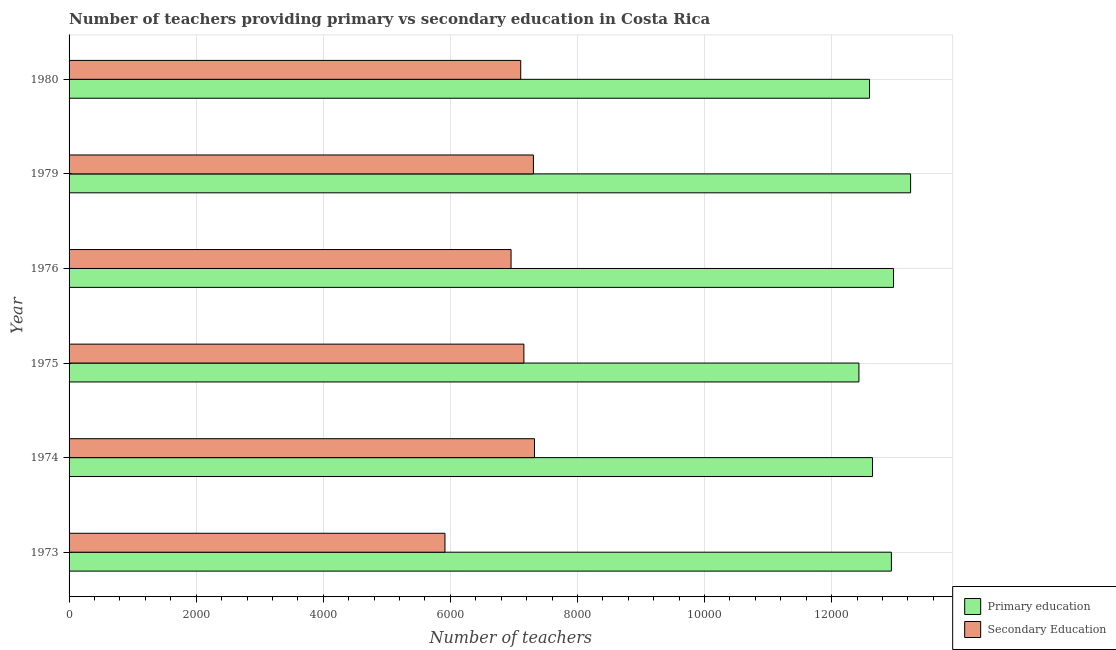How many groups of bars are there?
Provide a succinct answer. 6. How many bars are there on the 5th tick from the top?
Make the answer very short. 2. How many bars are there on the 5th tick from the bottom?
Offer a very short reply. 2. What is the label of the 3rd group of bars from the top?
Give a very brief answer. 1976. What is the number of secondary teachers in 1974?
Give a very brief answer. 7324. Across all years, what is the maximum number of secondary teachers?
Provide a succinct answer. 7324. Across all years, what is the minimum number of secondary teachers?
Offer a terse response. 5915. In which year was the number of secondary teachers maximum?
Offer a very short reply. 1974. In which year was the number of primary teachers minimum?
Your answer should be compact. 1975. What is the total number of secondary teachers in the graph?
Keep it short and to the point. 4.18e+04. What is the difference between the number of secondary teachers in 1973 and that in 1975?
Your answer should be compact. -1242. What is the difference between the number of primary teachers in 1973 and the number of secondary teachers in 1979?
Your response must be concise. 5633. What is the average number of secondary teachers per year?
Your answer should be very brief. 6960.83. In the year 1979, what is the difference between the number of secondary teachers and number of primary teachers?
Offer a terse response. -5935. What is the ratio of the number of secondary teachers in 1973 to that in 1975?
Your response must be concise. 0.83. Is the number of secondary teachers in 1974 less than that in 1979?
Give a very brief answer. No. What is the difference between the highest and the second highest number of primary teachers?
Make the answer very short. 269. What is the difference between the highest and the lowest number of primary teachers?
Your response must be concise. 813. What does the 2nd bar from the top in 1975 represents?
Give a very brief answer. Primary education. How many bars are there?
Offer a terse response. 12. How many years are there in the graph?
Your answer should be very brief. 6. What is the difference between two consecutive major ticks on the X-axis?
Your answer should be compact. 2000. Are the values on the major ticks of X-axis written in scientific E-notation?
Your answer should be compact. No. Does the graph contain any zero values?
Make the answer very short. No. Where does the legend appear in the graph?
Keep it short and to the point. Bottom right. What is the title of the graph?
Ensure brevity in your answer.  Number of teachers providing primary vs secondary education in Costa Rica. Does "By country of asylum" appear as one of the legend labels in the graph?
Provide a short and direct response. No. What is the label or title of the X-axis?
Ensure brevity in your answer.  Number of teachers. What is the label or title of the Y-axis?
Your answer should be compact. Year. What is the Number of teachers of Primary education in 1973?
Ensure brevity in your answer.  1.29e+04. What is the Number of teachers of Secondary Education in 1973?
Give a very brief answer. 5915. What is the Number of teachers of Primary education in 1974?
Provide a succinct answer. 1.26e+04. What is the Number of teachers in Secondary Education in 1974?
Your answer should be very brief. 7324. What is the Number of teachers of Primary education in 1975?
Offer a very short reply. 1.24e+04. What is the Number of teachers of Secondary Education in 1975?
Give a very brief answer. 7157. What is the Number of teachers in Primary education in 1976?
Give a very brief answer. 1.30e+04. What is the Number of teachers in Secondary Education in 1976?
Make the answer very short. 6955. What is the Number of teachers of Primary education in 1979?
Ensure brevity in your answer.  1.32e+04. What is the Number of teachers in Secondary Education in 1979?
Provide a succinct answer. 7307. What is the Number of teachers in Primary education in 1980?
Keep it short and to the point. 1.26e+04. What is the Number of teachers of Secondary Education in 1980?
Make the answer very short. 7107. Across all years, what is the maximum Number of teachers of Primary education?
Your answer should be compact. 1.32e+04. Across all years, what is the maximum Number of teachers of Secondary Education?
Keep it short and to the point. 7324. Across all years, what is the minimum Number of teachers of Primary education?
Offer a terse response. 1.24e+04. Across all years, what is the minimum Number of teachers in Secondary Education?
Keep it short and to the point. 5915. What is the total Number of teachers in Primary education in the graph?
Ensure brevity in your answer.  7.68e+04. What is the total Number of teachers in Secondary Education in the graph?
Your answer should be very brief. 4.18e+04. What is the difference between the Number of teachers of Primary education in 1973 and that in 1974?
Make the answer very short. 297. What is the difference between the Number of teachers in Secondary Education in 1973 and that in 1974?
Provide a succinct answer. -1409. What is the difference between the Number of teachers of Primary education in 1973 and that in 1975?
Provide a short and direct response. 511. What is the difference between the Number of teachers of Secondary Education in 1973 and that in 1975?
Offer a terse response. -1242. What is the difference between the Number of teachers of Primary education in 1973 and that in 1976?
Your response must be concise. -33. What is the difference between the Number of teachers in Secondary Education in 1973 and that in 1976?
Keep it short and to the point. -1040. What is the difference between the Number of teachers in Primary education in 1973 and that in 1979?
Give a very brief answer. -302. What is the difference between the Number of teachers in Secondary Education in 1973 and that in 1979?
Make the answer very short. -1392. What is the difference between the Number of teachers of Primary education in 1973 and that in 1980?
Offer a terse response. 344. What is the difference between the Number of teachers of Secondary Education in 1973 and that in 1980?
Provide a short and direct response. -1192. What is the difference between the Number of teachers in Primary education in 1974 and that in 1975?
Offer a terse response. 214. What is the difference between the Number of teachers in Secondary Education in 1974 and that in 1975?
Your answer should be compact. 167. What is the difference between the Number of teachers in Primary education in 1974 and that in 1976?
Give a very brief answer. -330. What is the difference between the Number of teachers of Secondary Education in 1974 and that in 1976?
Provide a succinct answer. 369. What is the difference between the Number of teachers in Primary education in 1974 and that in 1979?
Offer a terse response. -599. What is the difference between the Number of teachers of Secondary Education in 1974 and that in 1980?
Give a very brief answer. 217. What is the difference between the Number of teachers in Primary education in 1975 and that in 1976?
Your answer should be very brief. -544. What is the difference between the Number of teachers in Secondary Education in 1975 and that in 1976?
Offer a very short reply. 202. What is the difference between the Number of teachers in Primary education in 1975 and that in 1979?
Provide a succinct answer. -813. What is the difference between the Number of teachers in Secondary Education in 1975 and that in 1979?
Your answer should be compact. -150. What is the difference between the Number of teachers of Primary education in 1975 and that in 1980?
Your answer should be very brief. -167. What is the difference between the Number of teachers of Secondary Education in 1975 and that in 1980?
Provide a short and direct response. 50. What is the difference between the Number of teachers of Primary education in 1976 and that in 1979?
Provide a succinct answer. -269. What is the difference between the Number of teachers of Secondary Education in 1976 and that in 1979?
Offer a very short reply. -352. What is the difference between the Number of teachers in Primary education in 1976 and that in 1980?
Provide a short and direct response. 377. What is the difference between the Number of teachers of Secondary Education in 1976 and that in 1980?
Provide a succinct answer. -152. What is the difference between the Number of teachers in Primary education in 1979 and that in 1980?
Your answer should be compact. 646. What is the difference between the Number of teachers in Secondary Education in 1979 and that in 1980?
Provide a succinct answer. 200. What is the difference between the Number of teachers of Primary education in 1973 and the Number of teachers of Secondary Education in 1974?
Ensure brevity in your answer.  5616. What is the difference between the Number of teachers in Primary education in 1973 and the Number of teachers in Secondary Education in 1975?
Your answer should be compact. 5783. What is the difference between the Number of teachers in Primary education in 1973 and the Number of teachers in Secondary Education in 1976?
Your answer should be very brief. 5985. What is the difference between the Number of teachers of Primary education in 1973 and the Number of teachers of Secondary Education in 1979?
Offer a very short reply. 5633. What is the difference between the Number of teachers of Primary education in 1973 and the Number of teachers of Secondary Education in 1980?
Make the answer very short. 5833. What is the difference between the Number of teachers of Primary education in 1974 and the Number of teachers of Secondary Education in 1975?
Provide a succinct answer. 5486. What is the difference between the Number of teachers in Primary education in 1974 and the Number of teachers in Secondary Education in 1976?
Offer a terse response. 5688. What is the difference between the Number of teachers in Primary education in 1974 and the Number of teachers in Secondary Education in 1979?
Offer a very short reply. 5336. What is the difference between the Number of teachers in Primary education in 1974 and the Number of teachers in Secondary Education in 1980?
Keep it short and to the point. 5536. What is the difference between the Number of teachers in Primary education in 1975 and the Number of teachers in Secondary Education in 1976?
Your answer should be compact. 5474. What is the difference between the Number of teachers of Primary education in 1975 and the Number of teachers of Secondary Education in 1979?
Provide a succinct answer. 5122. What is the difference between the Number of teachers of Primary education in 1975 and the Number of teachers of Secondary Education in 1980?
Make the answer very short. 5322. What is the difference between the Number of teachers of Primary education in 1976 and the Number of teachers of Secondary Education in 1979?
Your response must be concise. 5666. What is the difference between the Number of teachers in Primary education in 1976 and the Number of teachers in Secondary Education in 1980?
Provide a short and direct response. 5866. What is the difference between the Number of teachers in Primary education in 1979 and the Number of teachers in Secondary Education in 1980?
Offer a very short reply. 6135. What is the average Number of teachers of Primary education per year?
Offer a very short reply. 1.28e+04. What is the average Number of teachers of Secondary Education per year?
Provide a succinct answer. 6960.83. In the year 1973, what is the difference between the Number of teachers in Primary education and Number of teachers in Secondary Education?
Provide a succinct answer. 7025. In the year 1974, what is the difference between the Number of teachers of Primary education and Number of teachers of Secondary Education?
Your response must be concise. 5319. In the year 1975, what is the difference between the Number of teachers in Primary education and Number of teachers in Secondary Education?
Your response must be concise. 5272. In the year 1976, what is the difference between the Number of teachers in Primary education and Number of teachers in Secondary Education?
Offer a terse response. 6018. In the year 1979, what is the difference between the Number of teachers in Primary education and Number of teachers in Secondary Education?
Ensure brevity in your answer.  5935. In the year 1980, what is the difference between the Number of teachers of Primary education and Number of teachers of Secondary Education?
Your answer should be compact. 5489. What is the ratio of the Number of teachers of Primary education in 1973 to that in 1974?
Offer a terse response. 1.02. What is the ratio of the Number of teachers in Secondary Education in 1973 to that in 1974?
Make the answer very short. 0.81. What is the ratio of the Number of teachers of Primary education in 1973 to that in 1975?
Give a very brief answer. 1.04. What is the ratio of the Number of teachers in Secondary Education in 1973 to that in 1975?
Your answer should be very brief. 0.83. What is the ratio of the Number of teachers of Primary education in 1973 to that in 1976?
Give a very brief answer. 1. What is the ratio of the Number of teachers of Secondary Education in 1973 to that in 1976?
Your response must be concise. 0.85. What is the ratio of the Number of teachers in Primary education in 1973 to that in 1979?
Keep it short and to the point. 0.98. What is the ratio of the Number of teachers of Secondary Education in 1973 to that in 1979?
Your answer should be compact. 0.81. What is the ratio of the Number of teachers of Primary education in 1973 to that in 1980?
Your answer should be very brief. 1.03. What is the ratio of the Number of teachers of Secondary Education in 1973 to that in 1980?
Keep it short and to the point. 0.83. What is the ratio of the Number of teachers of Primary education in 1974 to that in 1975?
Ensure brevity in your answer.  1.02. What is the ratio of the Number of teachers of Secondary Education in 1974 to that in 1975?
Make the answer very short. 1.02. What is the ratio of the Number of teachers of Primary education in 1974 to that in 1976?
Ensure brevity in your answer.  0.97. What is the ratio of the Number of teachers in Secondary Education in 1974 to that in 1976?
Your response must be concise. 1.05. What is the ratio of the Number of teachers of Primary education in 1974 to that in 1979?
Your answer should be very brief. 0.95. What is the ratio of the Number of teachers of Secondary Education in 1974 to that in 1979?
Ensure brevity in your answer.  1. What is the ratio of the Number of teachers in Secondary Education in 1974 to that in 1980?
Offer a very short reply. 1.03. What is the ratio of the Number of teachers of Primary education in 1975 to that in 1976?
Make the answer very short. 0.96. What is the ratio of the Number of teachers of Primary education in 1975 to that in 1979?
Your answer should be compact. 0.94. What is the ratio of the Number of teachers in Secondary Education in 1975 to that in 1979?
Provide a short and direct response. 0.98. What is the ratio of the Number of teachers of Primary education in 1975 to that in 1980?
Keep it short and to the point. 0.99. What is the ratio of the Number of teachers of Secondary Education in 1975 to that in 1980?
Provide a succinct answer. 1.01. What is the ratio of the Number of teachers of Primary education in 1976 to that in 1979?
Keep it short and to the point. 0.98. What is the ratio of the Number of teachers of Secondary Education in 1976 to that in 1979?
Offer a terse response. 0.95. What is the ratio of the Number of teachers in Primary education in 1976 to that in 1980?
Make the answer very short. 1.03. What is the ratio of the Number of teachers in Secondary Education in 1976 to that in 1980?
Your response must be concise. 0.98. What is the ratio of the Number of teachers in Primary education in 1979 to that in 1980?
Your response must be concise. 1.05. What is the ratio of the Number of teachers in Secondary Education in 1979 to that in 1980?
Make the answer very short. 1.03. What is the difference between the highest and the second highest Number of teachers in Primary education?
Offer a terse response. 269. What is the difference between the highest and the lowest Number of teachers of Primary education?
Make the answer very short. 813. What is the difference between the highest and the lowest Number of teachers of Secondary Education?
Offer a very short reply. 1409. 